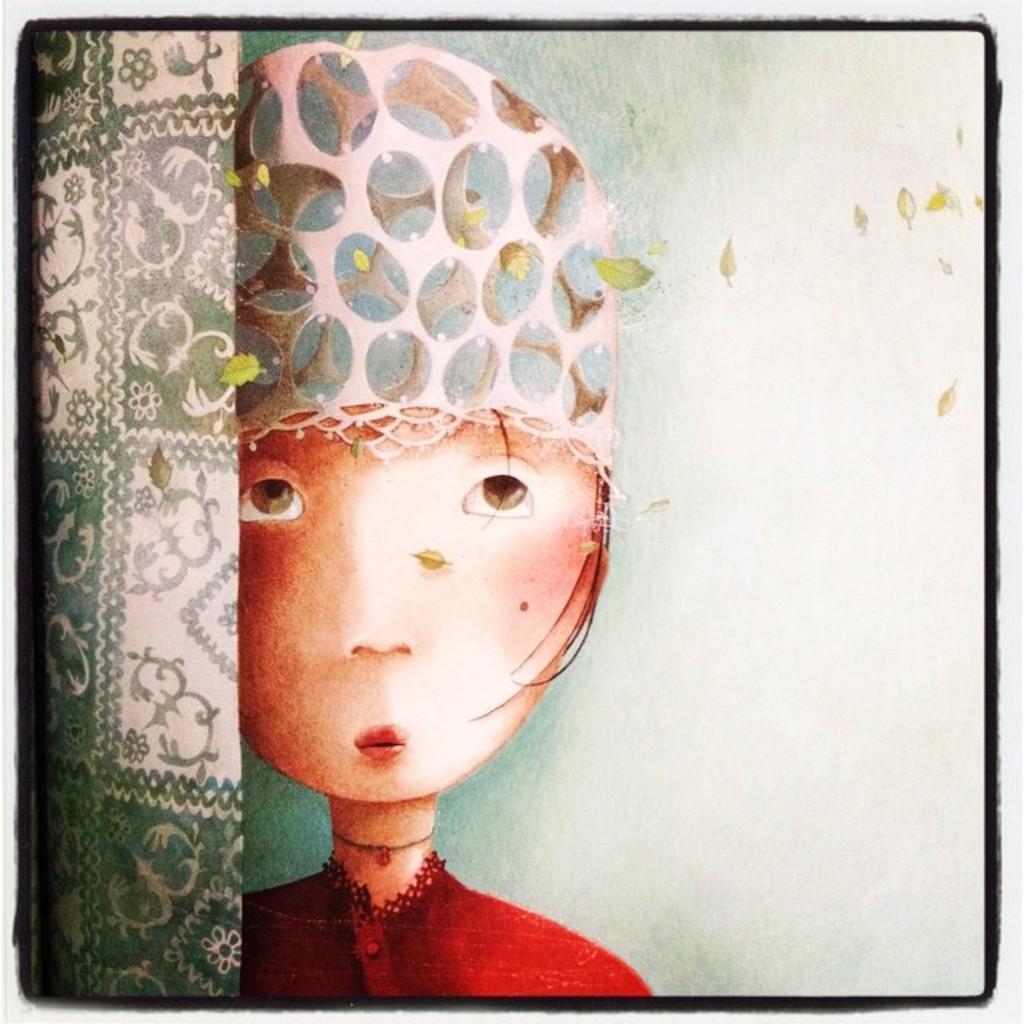Could you give a brief overview of what you see in this image? This picture seems to be an edited image with the borders and we can see the painting of a person and the paintings of some objects and the leaves. 